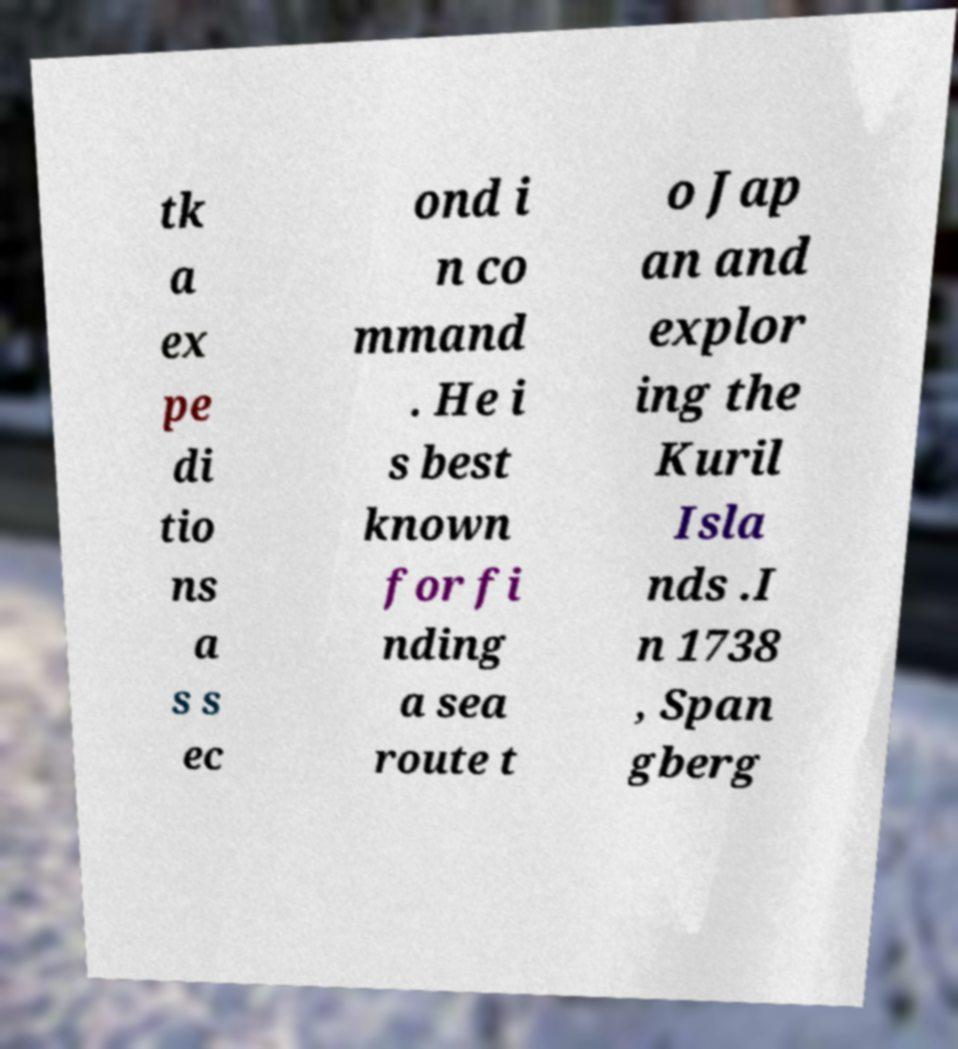I need the written content from this picture converted into text. Can you do that? tk a ex pe di tio ns a s s ec ond i n co mmand . He i s best known for fi nding a sea route t o Jap an and explor ing the Kuril Isla nds .I n 1738 , Span gberg 